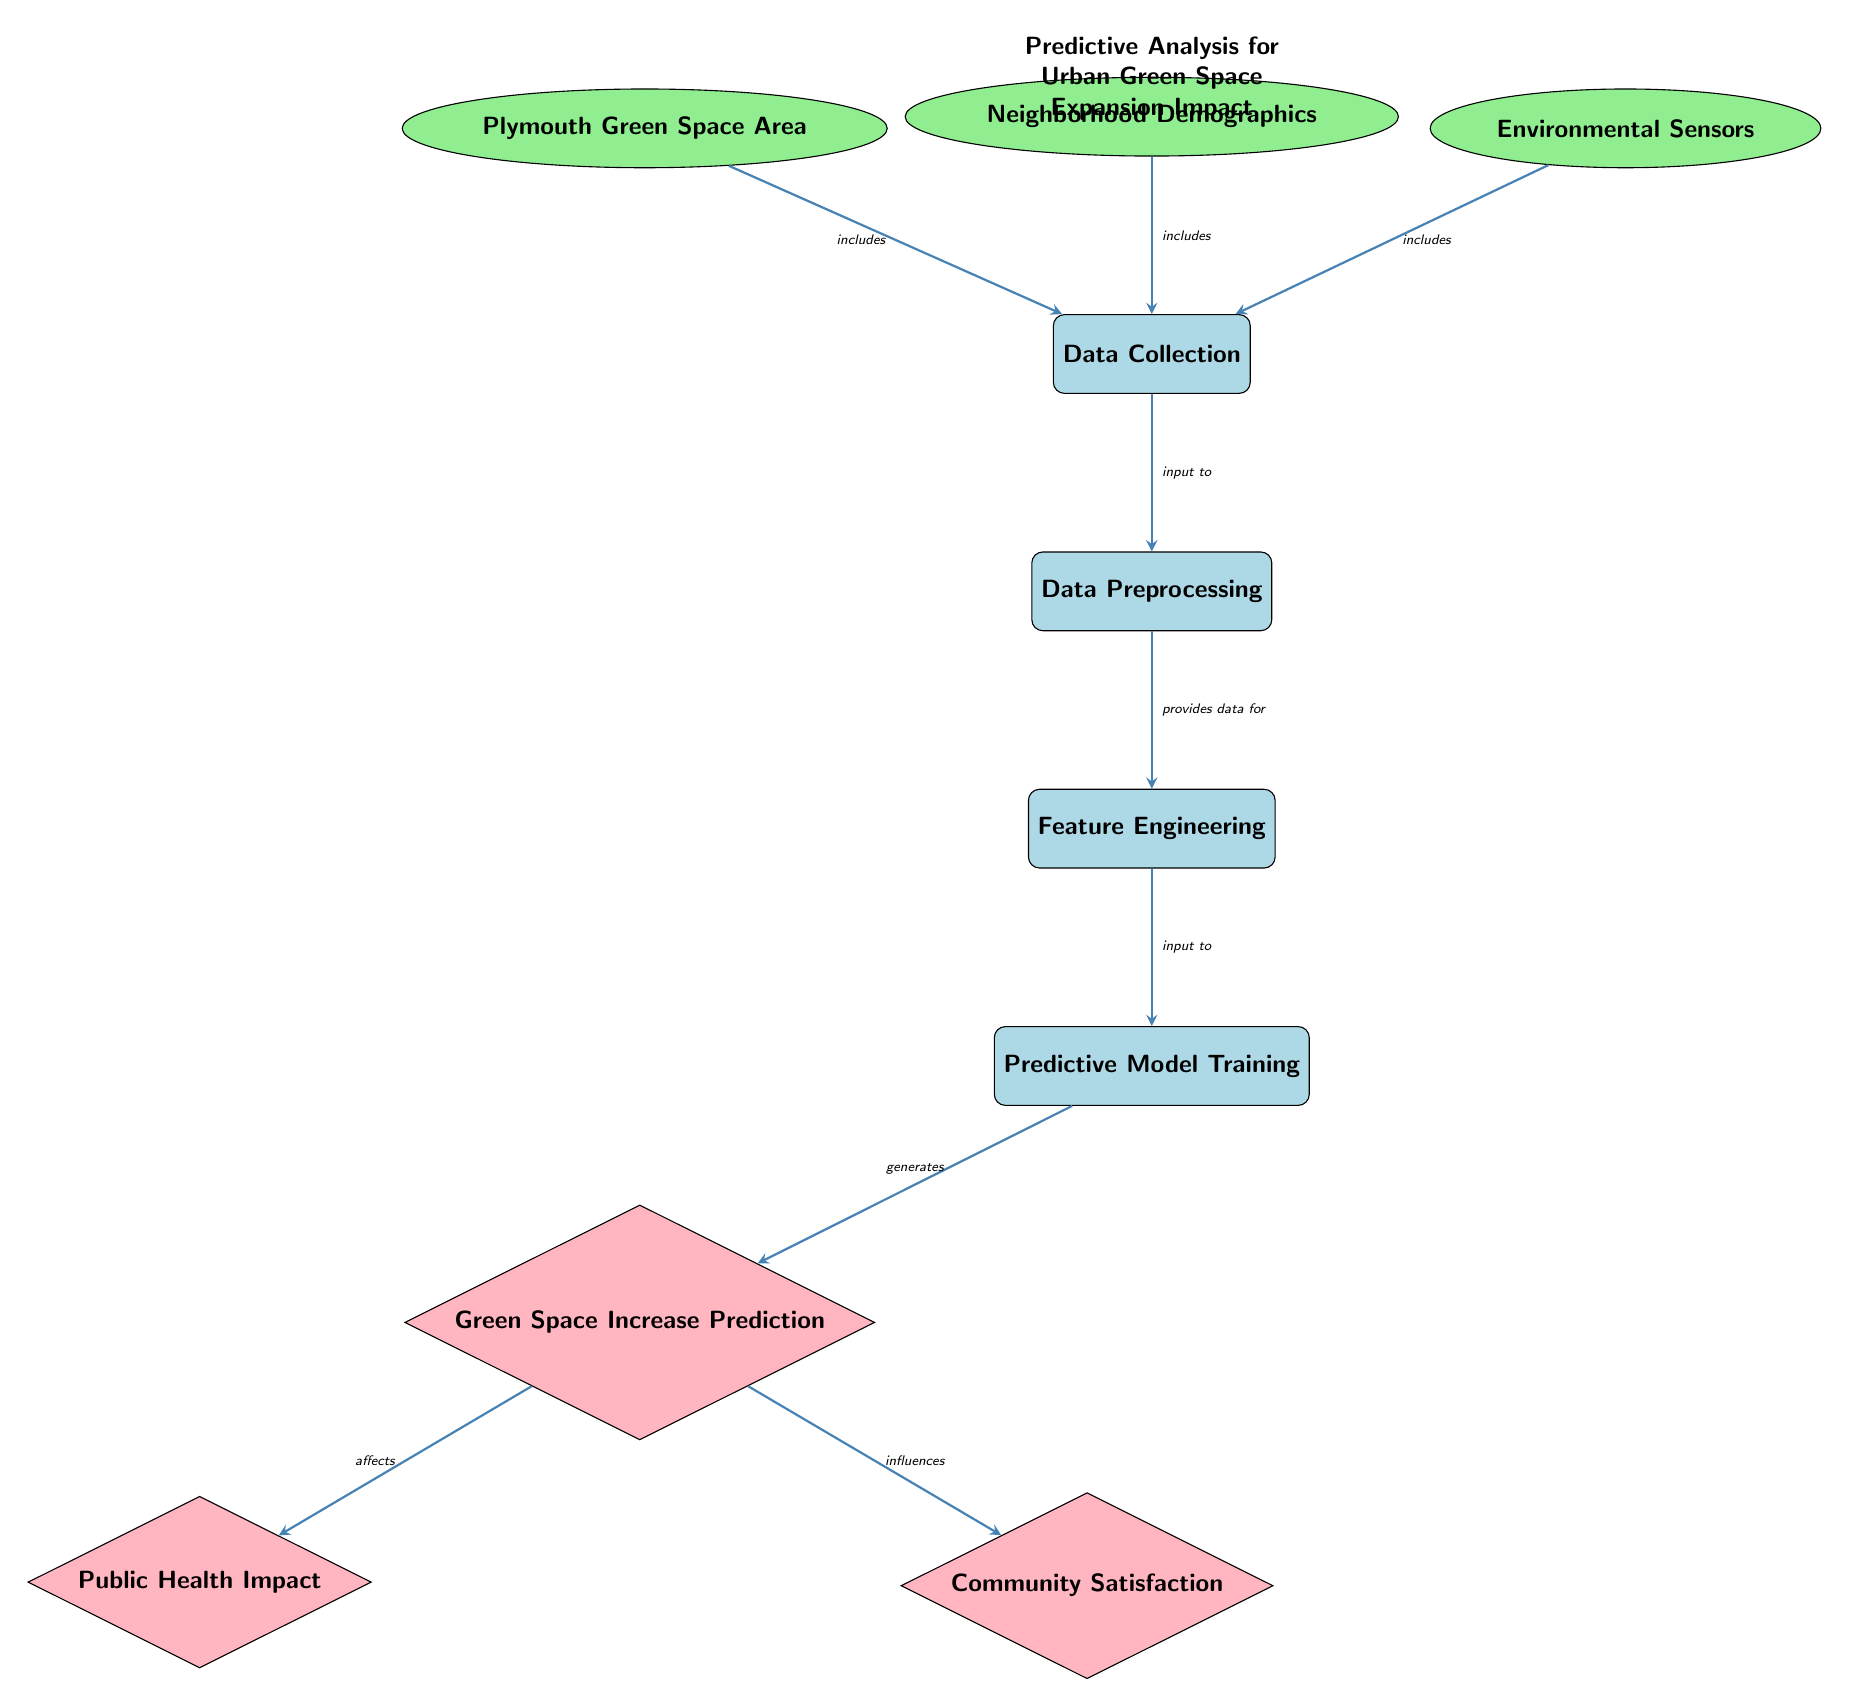What is the first process in the diagram? The first process node identified in the diagram is labeled "Data Collection." It is located at the top of the diagram.
Answer: Data Collection How many data nodes are in the diagram? Counting the nodes labeled with the data style, there are three data nodes: "Plymouth Green Space Area," "Neighborhood Demographics," and "Environmental Sensors."
Answer: 3 What does the "Data Preprocessing" process provide input to? The diagram shows that "Data Preprocessing" provides data for the next process labeled "Feature Engineering."
Answer: Feature Engineering Which output is influenced by the "Green Space Increase Prediction"? The diagram illustrates that "Community Satisfaction" is influenced by the "Green Space Increase Prediction."
Answer: Community Satisfaction What is the relationship between "Neighborhood Demographics" and "Data Collection"? The relationship depicted shows that "Neighborhood Demographics" is included in the "Data Collection" process, indicating that demographic data contributes to the overall data gathered.
Answer: includes What is the output generated after the "Predictive Model Training"? According to the diagram, the output generated after the "Predictive Model Training" is labeled "Green Space Increase Prediction."
Answer: Green Space Increase Prediction How many edges connect the processes in the diagram? By examining the arrows connecting the processes, there are six directed edges that connect various processes in the flow of the diagram.
Answer: 6 What effect does the "Green Space Increase Prediction" have? The diagram depicts that the "Green Space Increase Prediction" affects "Public Health Impact," showing a direct impact on health outcomes as a result of predicted changes in green space.
Answer: affects What is the last output process in the diagram? The last output process in the flow of the diagram is labeled "Community Satisfaction," which follows after "Green Space Increase Prediction."
Answer: Community Satisfaction 